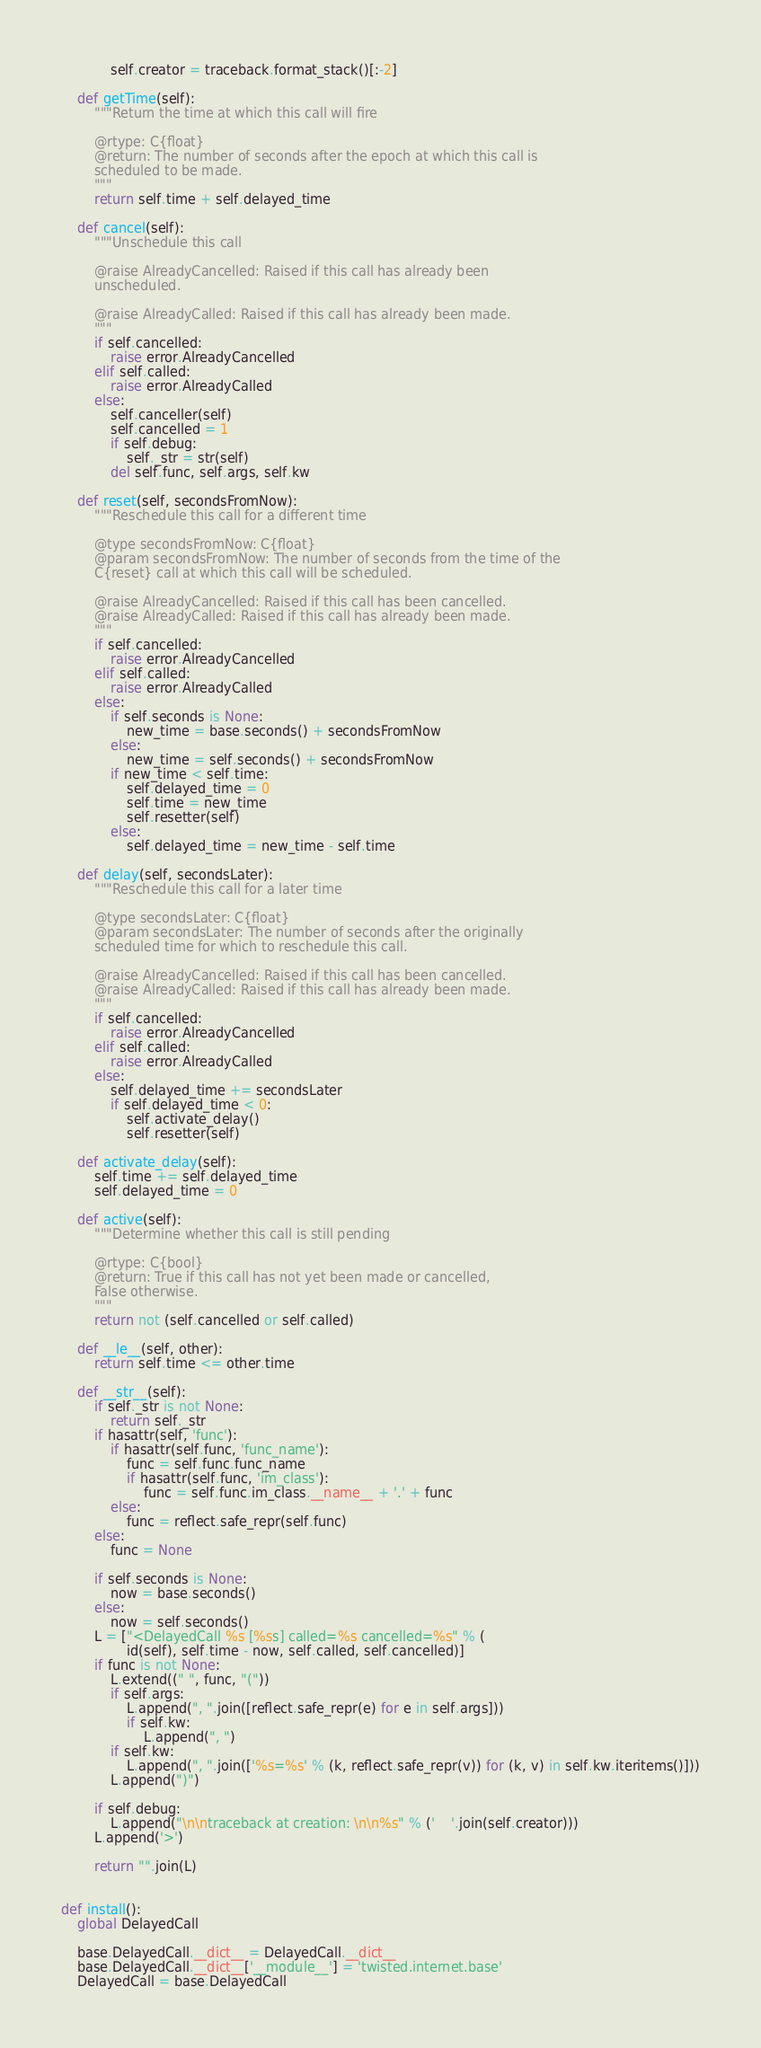<code> <loc_0><loc_0><loc_500><loc_500><_Python_>            self.creator = traceback.format_stack()[:-2]

    def getTime(self):
        """Return the time at which this call will fire

        @rtype: C{float}
        @return: The number of seconds after the epoch at which this call is
        scheduled to be made.
        """
        return self.time + self.delayed_time

    def cancel(self):
        """Unschedule this call

        @raise AlreadyCancelled: Raised if this call has already been
        unscheduled.

        @raise AlreadyCalled: Raised if this call has already been made.
        """
        if self.cancelled:
            raise error.AlreadyCancelled
        elif self.called:
            raise error.AlreadyCalled
        else:
            self.canceller(self)
            self.cancelled = 1
            if self.debug:
                self._str = str(self)
            del self.func, self.args, self.kw

    def reset(self, secondsFromNow):
        """Reschedule this call for a different time

        @type secondsFromNow: C{float}
        @param secondsFromNow: The number of seconds from the time of the
        C{reset} call at which this call will be scheduled.

        @raise AlreadyCancelled: Raised if this call has been cancelled.
        @raise AlreadyCalled: Raised if this call has already been made.
        """
        if self.cancelled:
            raise error.AlreadyCancelled
        elif self.called:
            raise error.AlreadyCalled
        else:
            if self.seconds is None:
                new_time = base.seconds() + secondsFromNow
            else:
                new_time = self.seconds() + secondsFromNow
            if new_time < self.time:
                self.delayed_time = 0
                self.time = new_time
                self.resetter(self)
            else:
                self.delayed_time = new_time - self.time

    def delay(self, secondsLater):
        """Reschedule this call for a later time

        @type secondsLater: C{float}
        @param secondsLater: The number of seconds after the originally
        scheduled time for which to reschedule this call.

        @raise AlreadyCancelled: Raised if this call has been cancelled.
        @raise AlreadyCalled: Raised if this call has already been made.
        """
        if self.cancelled:
            raise error.AlreadyCancelled
        elif self.called:
            raise error.AlreadyCalled
        else:
            self.delayed_time += secondsLater
            if self.delayed_time < 0:
                self.activate_delay()
                self.resetter(self)

    def activate_delay(self):
        self.time += self.delayed_time
        self.delayed_time = 0

    def active(self):
        """Determine whether this call is still pending

        @rtype: C{bool}
        @return: True if this call has not yet been made or cancelled,
        False otherwise.
        """
        return not (self.cancelled or self.called)

    def __le__(self, other):
        return self.time <= other.time

    def __str__(self):
        if self._str is not None:
            return self._str
        if hasattr(self, 'func'):
            if hasattr(self.func, 'func_name'):
                func = self.func.func_name
                if hasattr(self.func, 'im_class'):
                    func = self.func.im_class.__name__ + '.' + func
            else:
                func = reflect.safe_repr(self.func)
        else:
            func = None

        if self.seconds is None:
            now = base.seconds()
        else:
            now = self.seconds()
        L = ["<DelayedCall %s [%ss] called=%s cancelled=%s" % (
                id(self), self.time - now, self.called, self.cancelled)]
        if func is not None:
            L.extend((" ", func, "("))
            if self.args:
                L.append(", ".join([reflect.safe_repr(e) for e in self.args]))
                if self.kw:
                    L.append(", ")
            if self.kw:
                L.append(", ".join(['%s=%s' % (k, reflect.safe_repr(v)) for (k, v) in self.kw.iteritems()]))
            L.append(")")

        if self.debug:
            L.append("\n\ntraceback at creation: \n\n%s" % ('    '.join(self.creator)))
        L.append('>')

        return "".join(L)


def install():
    global DelayedCall

    base.DelayedCall.__dict__ = DelayedCall.__dict__
    base.DelayedCall.__dict__['__module__'] = 'twisted.internet.base'
    DelayedCall = base.DelayedCall
</code> 